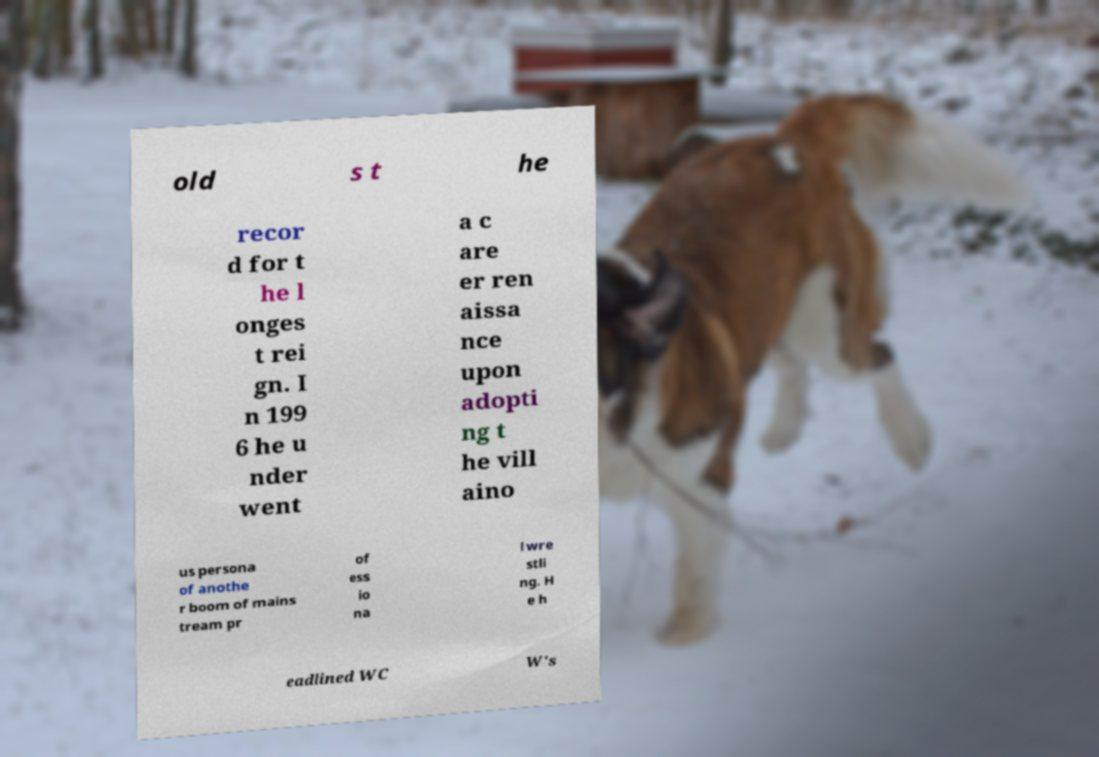Could you assist in decoding the text presented in this image and type it out clearly? old s t he recor d for t he l onges t rei gn. I n 199 6 he u nder went a c are er ren aissa nce upon adopti ng t he vill aino us persona of anothe r boom of mains tream pr of ess io na l wre stli ng. H e h eadlined WC W's 